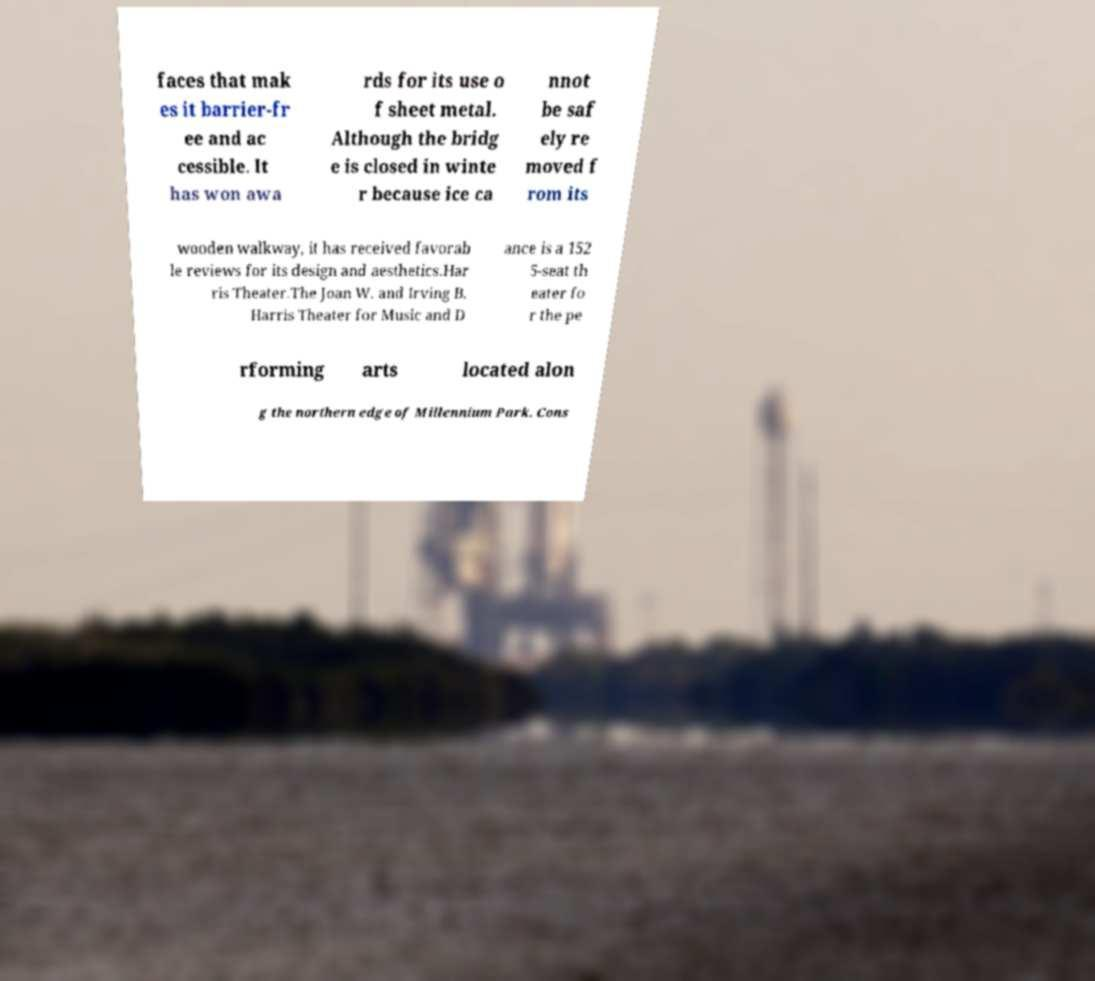Can you read and provide the text displayed in the image?This photo seems to have some interesting text. Can you extract and type it out for me? faces that mak es it barrier-fr ee and ac cessible. It has won awa rds for its use o f sheet metal. Although the bridg e is closed in winte r because ice ca nnot be saf ely re moved f rom its wooden walkway, it has received favorab le reviews for its design and aesthetics.Har ris Theater.The Joan W. and Irving B. Harris Theater for Music and D ance is a 152 5-seat th eater fo r the pe rforming arts located alon g the northern edge of Millennium Park. Cons 